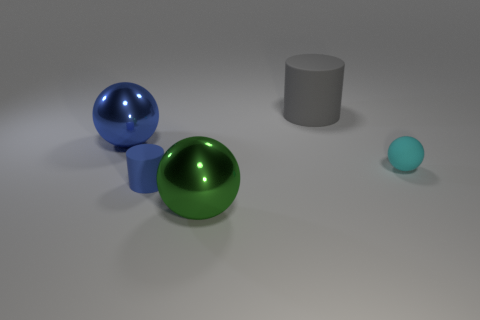What number of other things are there of the same color as the small matte cylinder?
Ensure brevity in your answer.  1. Are any gray matte cylinders visible?
Give a very brief answer. Yes. What material is the thing left of the blue cylinder?
Offer a very short reply. Metal. What material is the object that is the same color as the small matte cylinder?
Provide a short and direct response. Metal. What number of big objects are cylinders or red metallic objects?
Offer a very short reply. 1. What is the color of the large matte thing?
Provide a short and direct response. Gray. There is a sphere that is on the right side of the large gray rubber thing; is there a matte ball that is on the right side of it?
Offer a terse response. No. Are there fewer big things right of the big rubber cylinder than large brown objects?
Your answer should be very brief. No. Are the big object in front of the cyan matte object and the big gray thing made of the same material?
Give a very brief answer. No. There is a large cylinder that is the same material as the cyan thing; what color is it?
Your response must be concise. Gray. 